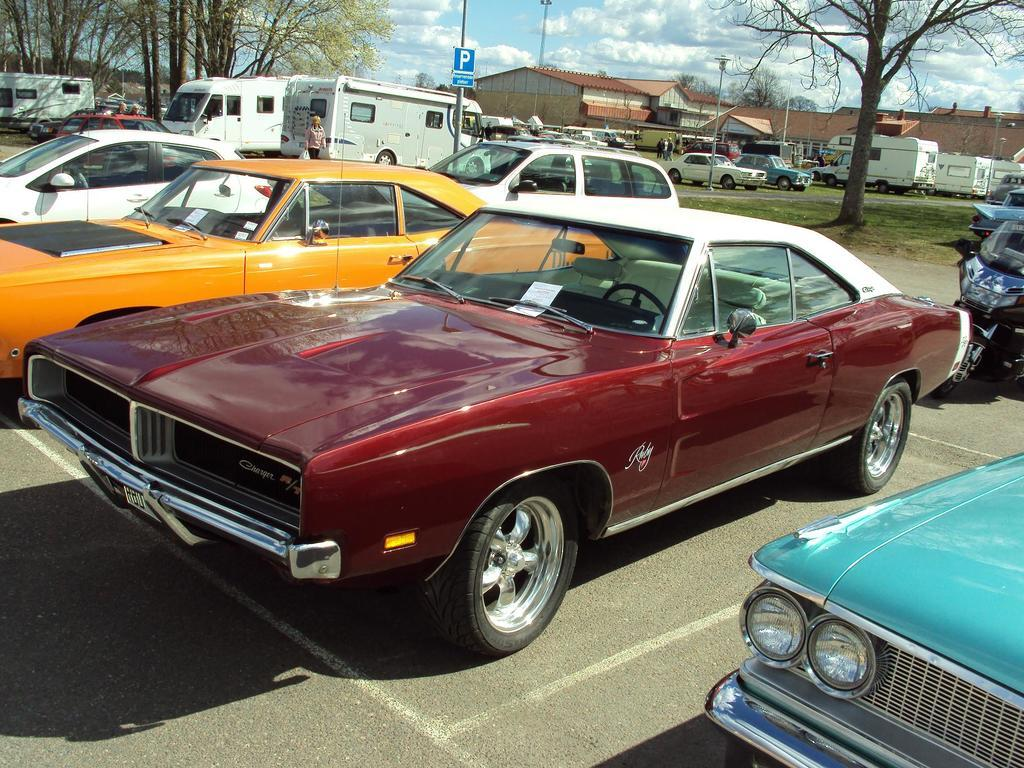What types of objects can be seen in the image? There are vehicles, poles, boards, lights, houses, and trees in the image. What else can be seen in the image besides objects? There is a group of people standing in the image. What is the background of the image? The sky is visible in the background of the image. Can you tell me how many desks are in the image? There are no desks present in the image. What type of request is being made by the people in the image? There is no indication of a request being made in the image; the people are simply standing. 